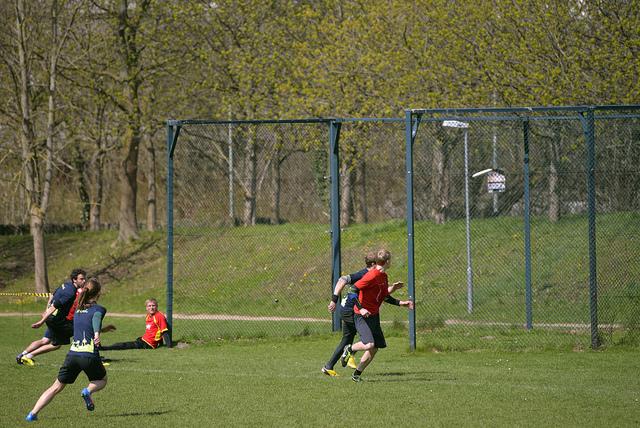Could the season be early spring?
Short answer required. Yes. Which sport is this?
Keep it brief. Frisbee. Is a field shown, or a stadium?
Be succinct. Field. Are there  trees in the picture?
Be succinct. Yes. 